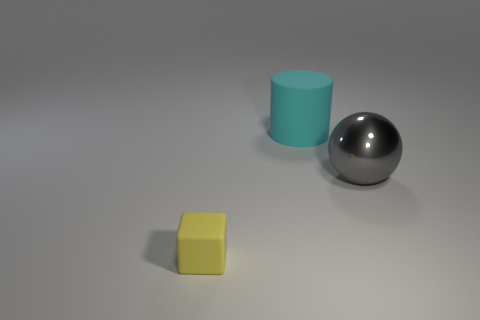Are there any other things that have the same size as the rubber block?
Ensure brevity in your answer.  No. What size is the object that is both in front of the big cyan matte cylinder and on the right side of the small yellow block?
Your answer should be very brief. Large. Is the number of cyan matte cylinders that are left of the large cylinder less than the number of yellow objects that are behind the gray sphere?
Make the answer very short. No. Do the small block in front of the big shiny thing and the big object in front of the matte cylinder have the same material?
Your answer should be very brief. No. What shape is the thing that is in front of the cylinder and behind the yellow block?
Give a very brief answer. Sphere. There is a object right of the rubber object that is behind the large gray object; what is it made of?
Your answer should be very brief. Metal. Are there more cyan cylinders than big objects?
Provide a succinct answer. No. What material is the thing that is the same size as the cylinder?
Provide a succinct answer. Metal. Does the big cyan object have the same material as the gray ball?
Ensure brevity in your answer.  No. How many cyan objects have the same material as the small yellow block?
Keep it short and to the point. 1. 